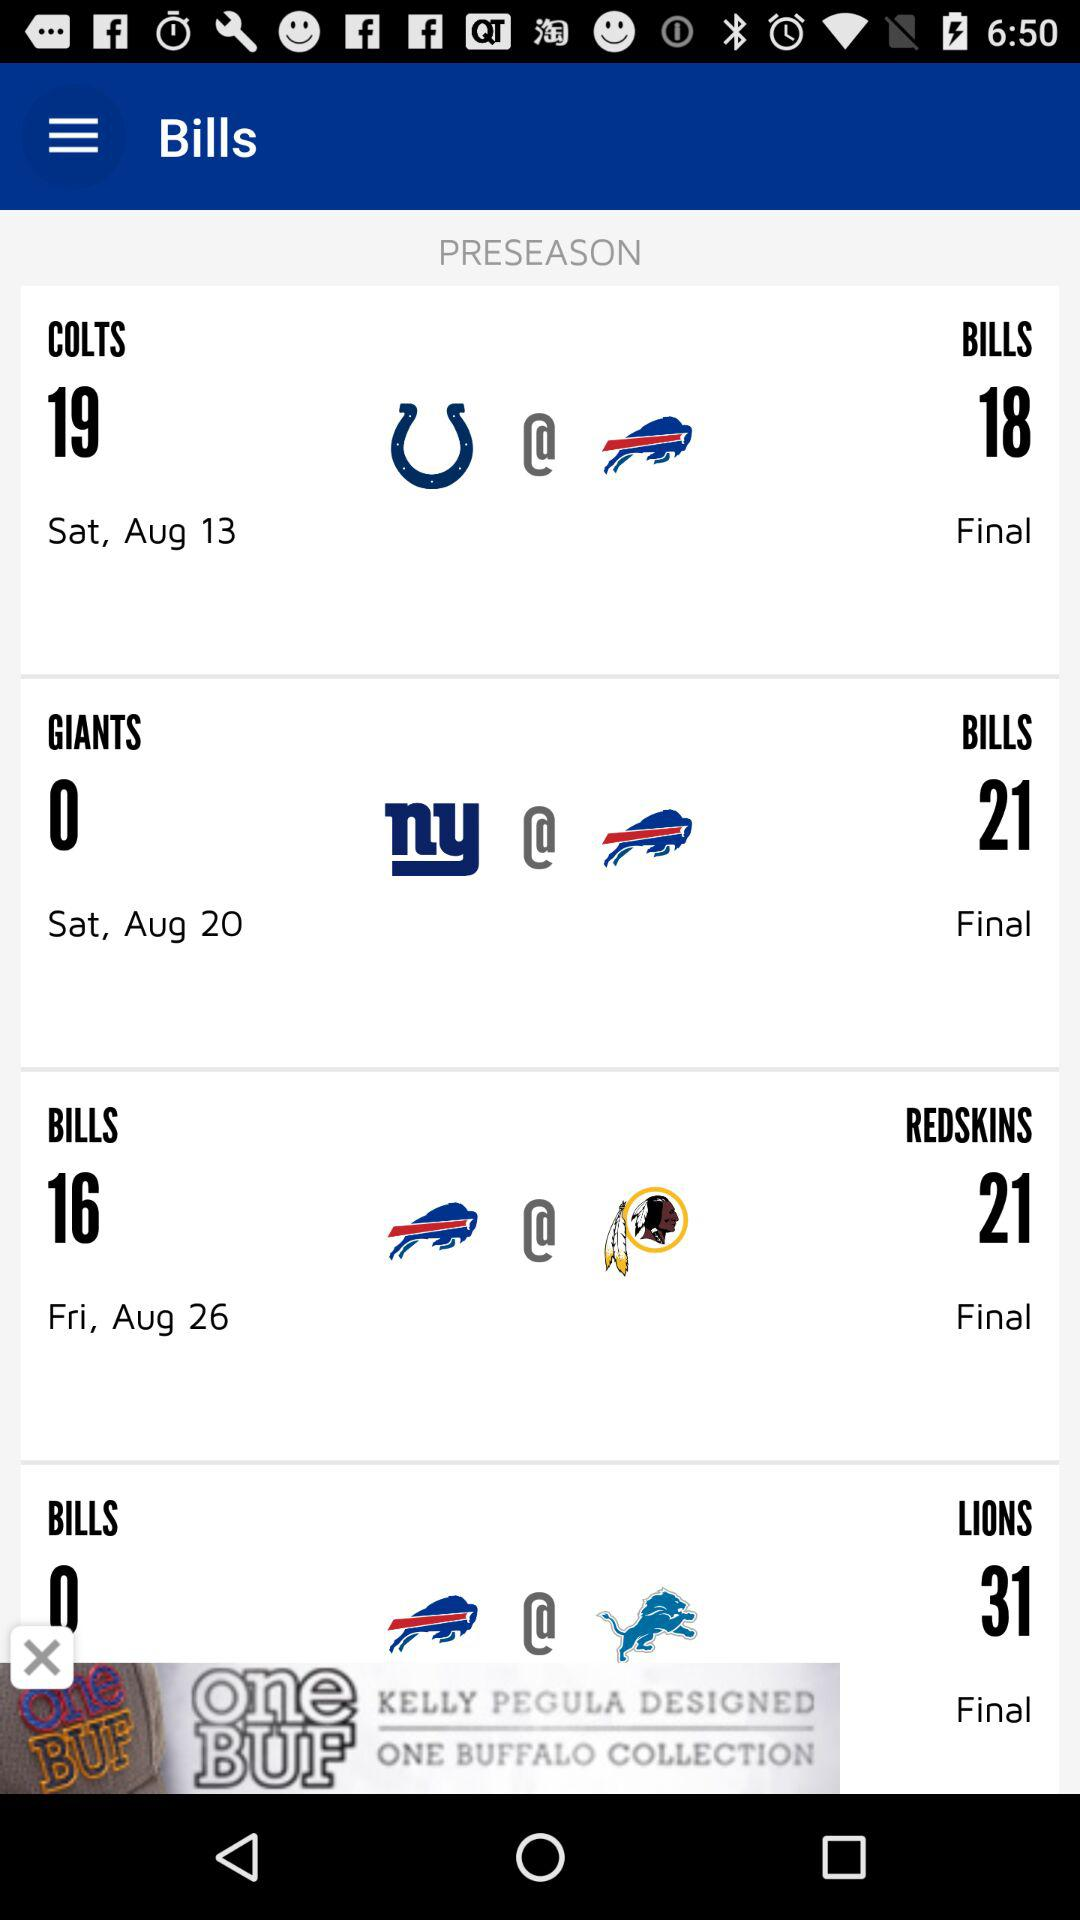What is the date of the final match between "GIANTS and BILLS"? The date is Saturday, August 20. 